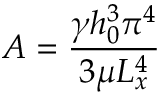<formula> <loc_0><loc_0><loc_500><loc_500>A = \frac { \gamma h _ { 0 } ^ { 3 } \pi ^ { 4 } } { 3 \mu L _ { x } ^ { 4 } }</formula> 